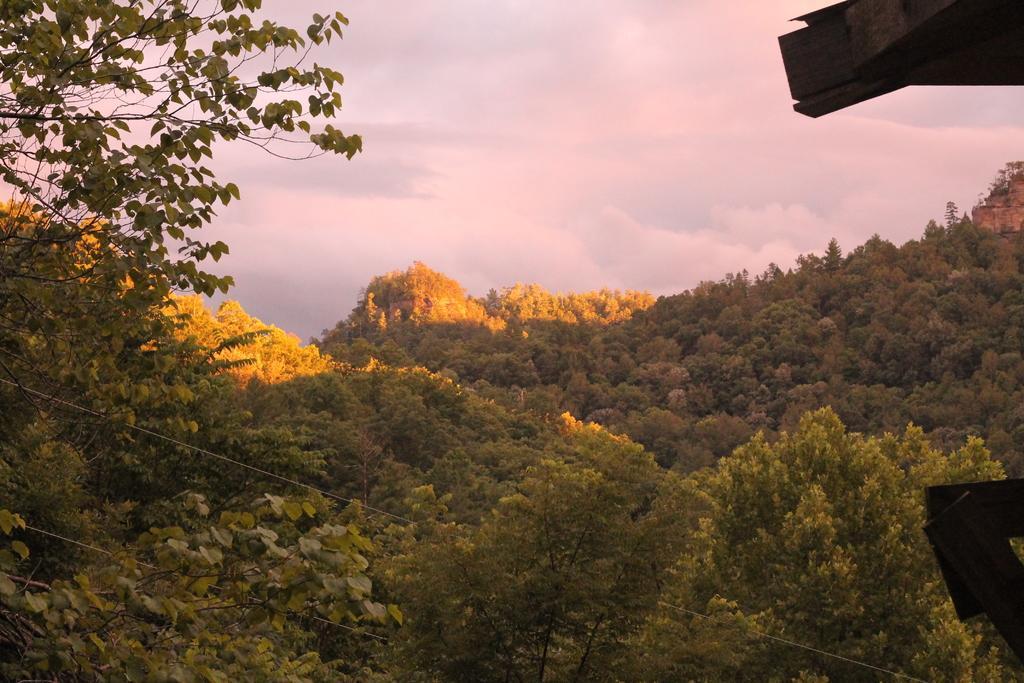Describe this image in one or two sentences. In this image we can see a group of trees, cables, some wooden boards and in the background we can see the cloudy sky. 